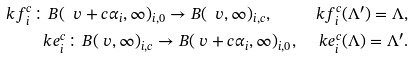Convert formula to latex. <formula><loc_0><loc_0><loc_500><loc_500>\ k f _ { i } ^ { c } \colon B ( \ v + c \alpha _ { i } , \infty ) _ { i , 0 } \to B ( \ v , \infty ) _ { i , c } , \quad \ k f _ { i } ^ { c } ( \Lambda ^ { \prime } ) = \Lambda , \\ \ k e _ { i } ^ { c } \colon B ( \ v , \infty ) _ { i , c } \to B ( \ v + c \alpha _ { i } , \infty ) _ { i , 0 } , \quad \ k e _ { i } ^ { c } ( \Lambda ) = \Lambda ^ { \prime } .</formula> 